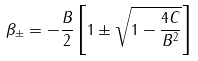<formula> <loc_0><loc_0><loc_500><loc_500>\beta _ { \pm } = - \frac { B } { 2 } \left [ 1 \pm \sqrt { 1 - \frac { 4 C } { B ^ { 2 } } } \right ]</formula> 